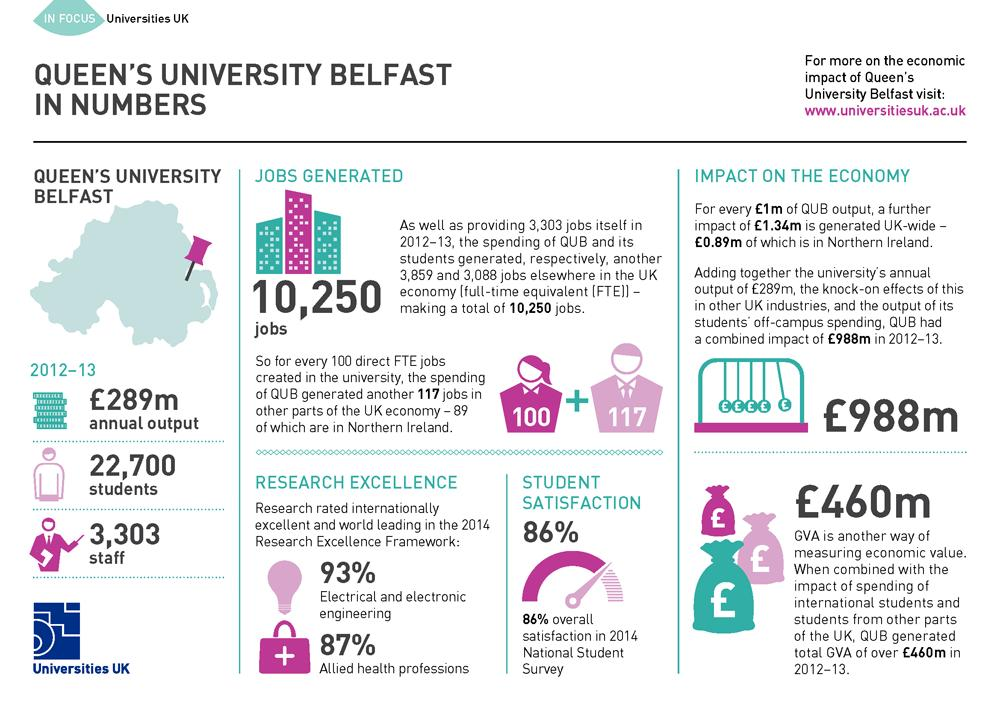Draw attention to some important aspects in this diagram. During the 2012-2013 academic year, approximately 3,303 staff members were employed by Queen's University Belfast. In the 2014 National Student Survey, 86% of students reported overall satisfaction. During the academic year 2012-2013, there were approximately 22,700 students enrolled at Queen's University Belfast. 